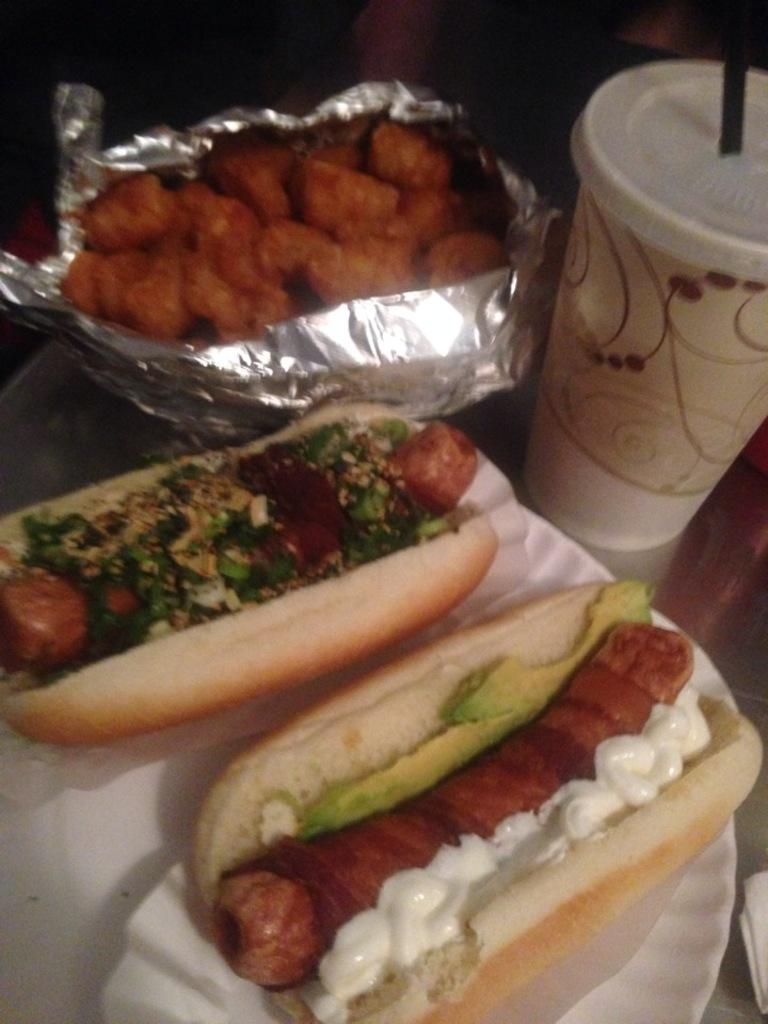What is on the plate that is visible in the image? There is a plate with food in the image. What type of container is present in the image? There is a cup in the image. How is the food on the plate being covered or protected? The food is wrapped in aluminium foil. On what surface are the plate, cup, and foil placed? The plate, cup, and foil are on a brown surface. Can you hear the sound of the veil in the image? There is no veil present in the image, so it is not possible to hear any sound related to it. 